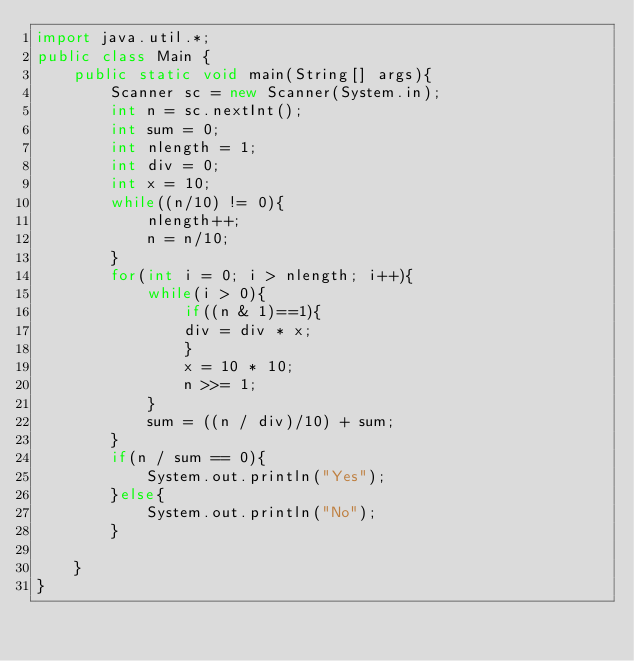<code> <loc_0><loc_0><loc_500><loc_500><_Java_>import java.util.*;
public class Main {
    public static void main(String[] args){
        Scanner sc = new Scanner(System.in);
        int n = sc.nextInt();
        int sum = 0;
        int nlength = 1;
        int div = 0;
        int x = 10;
        while((n/10) != 0){
            nlength++;
            n = n/10;
        }
        for(int i = 0; i > nlength; i++){
            while(i > 0){
                if((n & 1)==1){
                div = div * x;
                }
                x = 10 * 10;
                n >>= 1;
            }
            sum = ((n / div)/10) + sum;
        }
        if(n / sum == 0){
            System.out.println("Yes");
        }else{
            System.out.println("No");
        }
        
    }
}</code> 